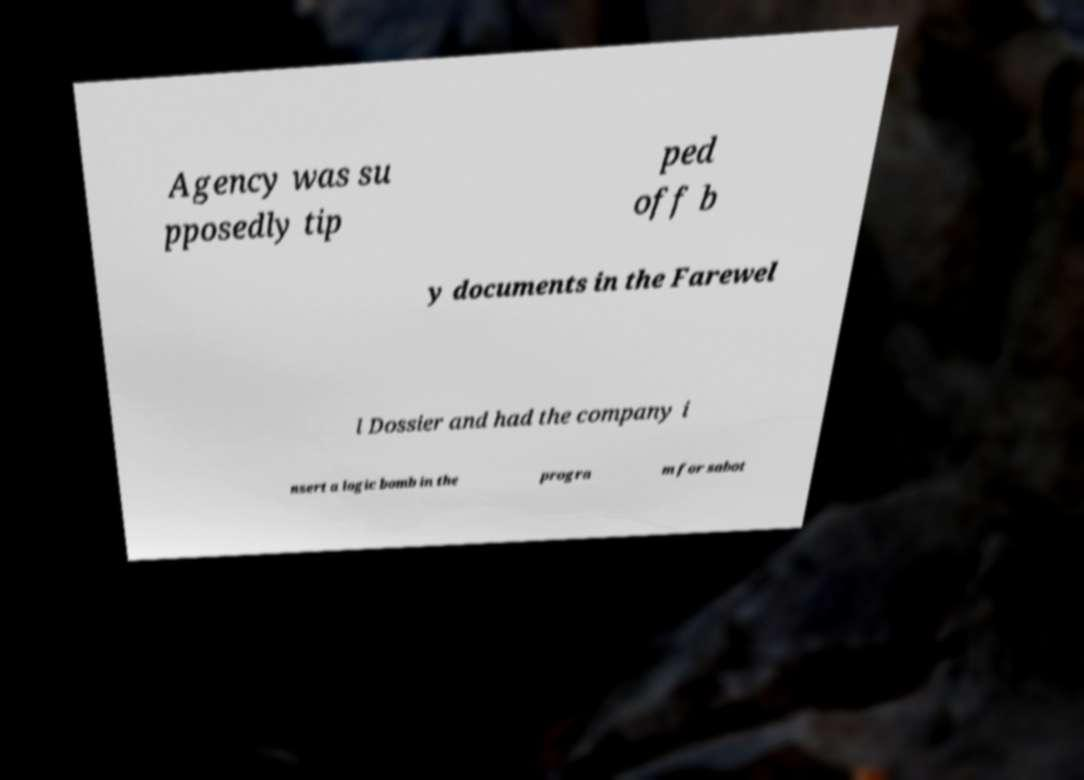Can you read and provide the text displayed in the image?This photo seems to have some interesting text. Can you extract and type it out for me? Agency was su pposedly tip ped off b y documents in the Farewel l Dossier and had the company i nsert a logic bomb in the progra m for sabot 